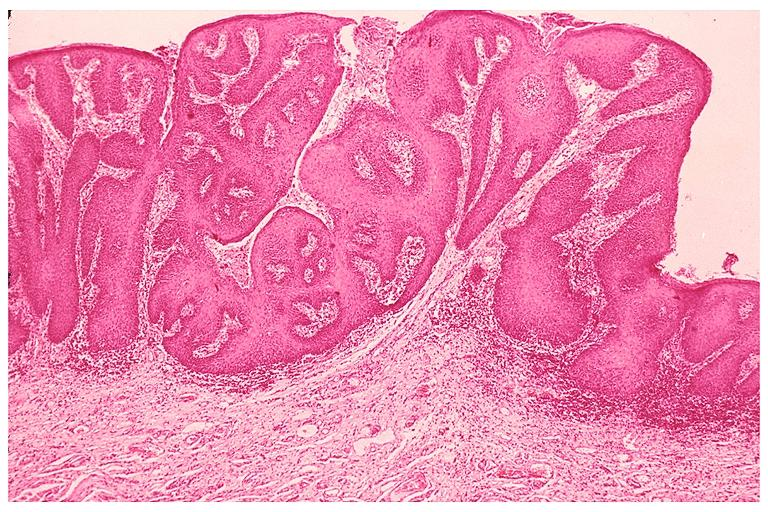where is this?
Answer the question using a single word or phrase. Oral 